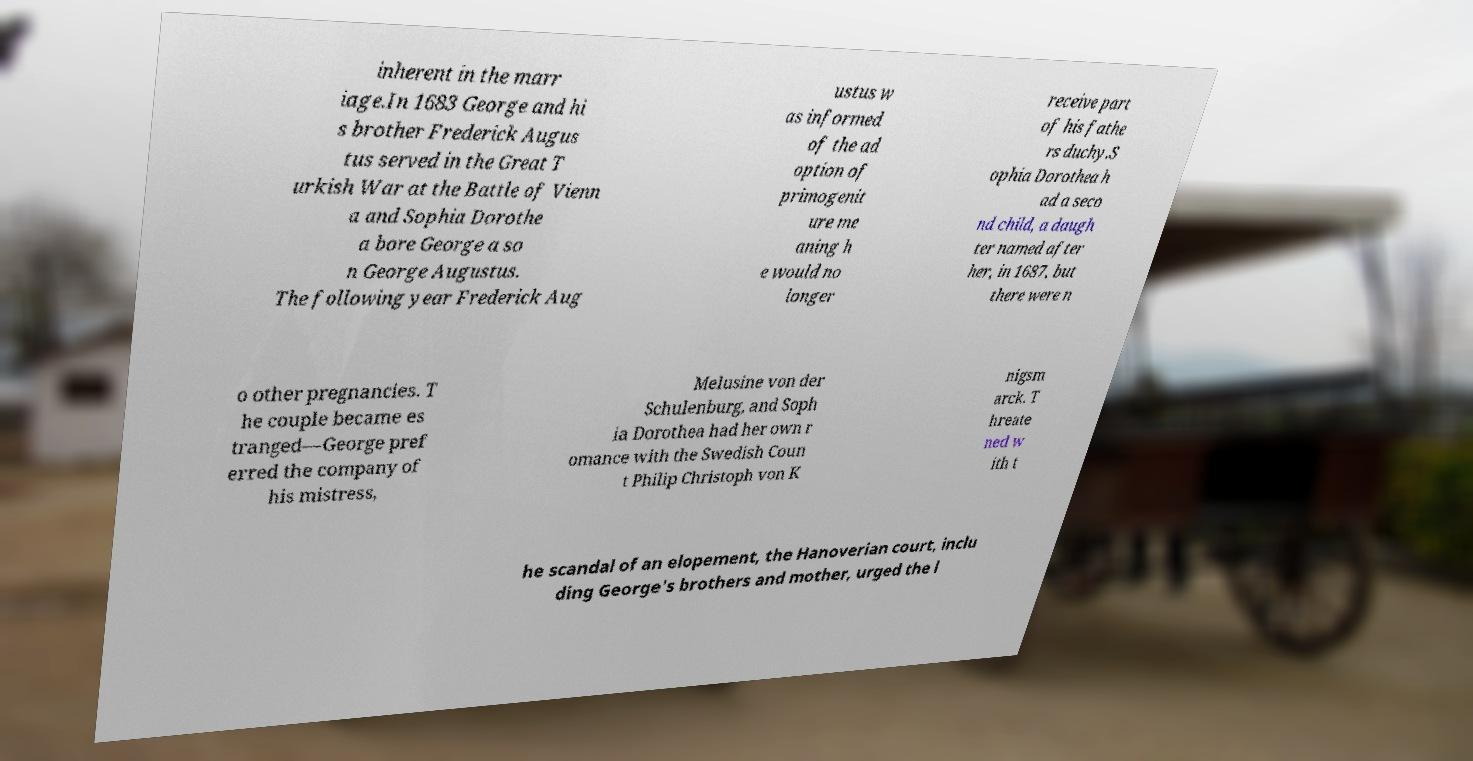What messages or text are displayed in this image? I need them in a readable, typed format. inherent in the marr iage.In 1683 George and hi s brother Frederick Augus tus served in the Great T urkish War at the Battle of Vienn a and Sophia Dorothe a bore George a so n George Augustus. The following year Frederick Aug ustus w as informed of the ad option of primogenit ure me aning h e would no longer receive part of his fathe rs duchy.S ophia Dorothea h ad a seco nd child, a daugh ter named after her, in 1687, but there were n o other pregnancies. T he couple became es tranged—George pref erred the company of his mistress, Melusine von der Schulenburg, and Soph ia Dorothea had her own r omance with the Swedish Coun t Philip Christoph von K nigsm arck. T hreate ned w ith t he scandal of an elopement, the Hanoverian court, inclu ding George's brothers and mother, urged the l 